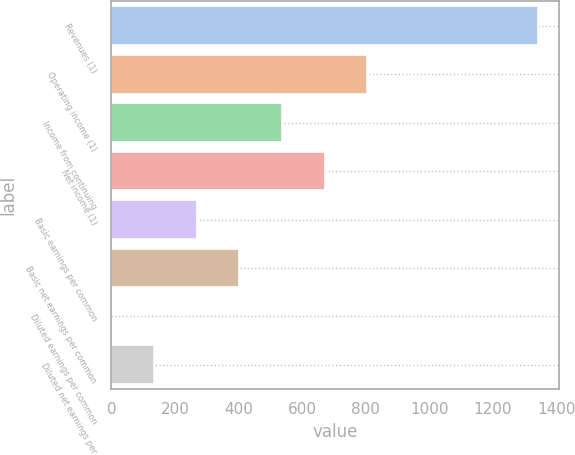<chart> <loc_0><loc_0><loc_500><loc_500><bar_chart><fcel>Revenues (1)<fcel>Operating income (1)<fcel>Income from continuing<fcel>Net income (1)<fcel>Basic earnings per common<fcel>Basic net earnings per common<fcel>Diluted earnings per common<fcel>Diluted net earnings per<nl><fcel>1341<fcel>804.71<fcel>536.57<fcel>670.64<fcel>268.43<fcel>402.5<fcel>0.29<fcel>134.36<nl></chart> 